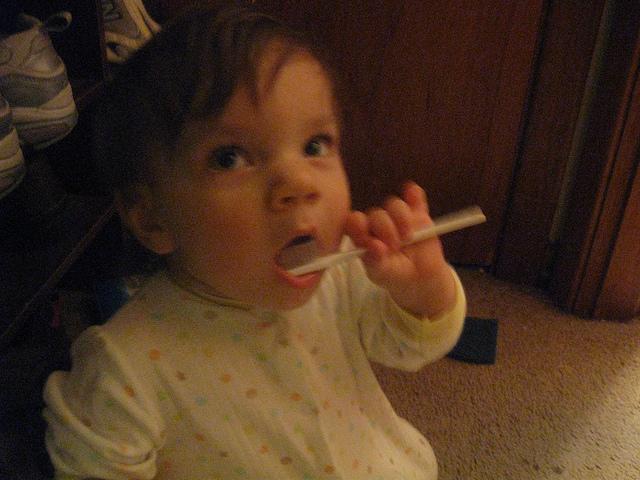What type of shoes are shown?
Answer briefly. Sneakers. What is this child doing?
Keep it brief. Brushing teeth. Does the baby have teeth?
Concise answer only. Yes. 